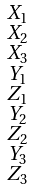Convert formula to latex. <formula><loc_0><loc_0><loc_500><loc_500>\begin{smallmatrix} X _ { 1 } \\ X _ { 2 } \\ X _ { 3 } \\ Y _ { 1 } \\ Z _ { 1 } \\ Y _ { 2 } \\ Z _ { 2 } \\ Y _ { 3 } \\ Z _ { 3 } \end{smallmatrix}</formula> 